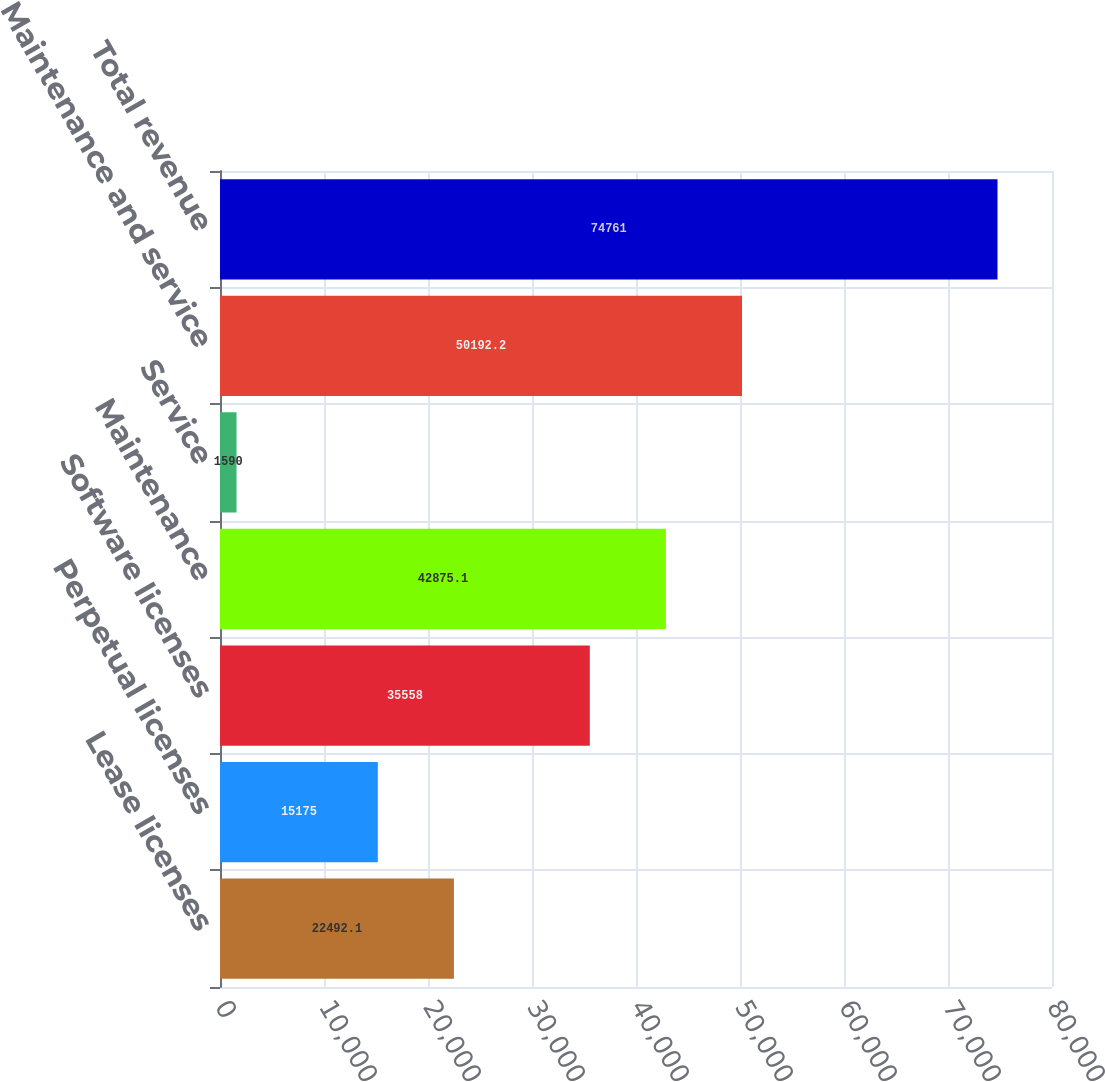Convert chart. <chart><loc_0><loc_0><loc_500><loc_500><bar_chart><fcel>Lease licenses<fcel>Perpetual licenses<fcel>Software licenses<fcel>Maintenance<fcel>Service<fcel>Maintenance and service<fcel>Total revenue<nl><fcel>22492.1<fcel>15175<fcel>35558<fcel>42875.1<fcel>1590<fcel>50192.2<fcel>74761<nl></chart> 